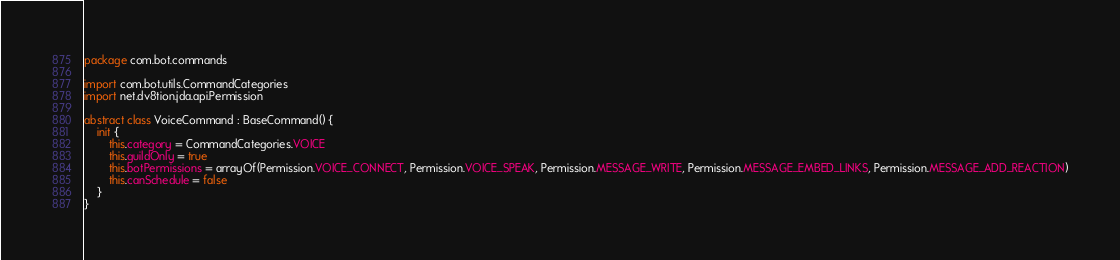<code> <loc_0><loc_0><loc_500><loc_500><_Kotlin_>package com.bot.commands

import com.bot.utils.CommandCategories
import net.dv8tion.jda.api.Permission

abstract class VoiceCommand : BaseCommand() {
    init {
        this.category = CommandCategories.VOICE
        this.guildOnly = true
        this.botPermissions = arrayOf(Permission.VOICE_CONNECT, Permission.VOICE_SPEAK, Permission.MESSAGE_WRITE, Permission.MESSAGE_EMBED_LINKS, Permission.MESSAGE_ADD_REACTION)
        this.canSchedule = false
    }
}
</code> 